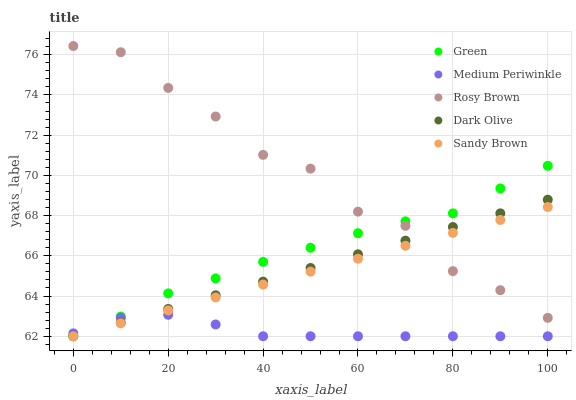Does Medium Periwinkle have the minimum area under the curve?
Answer yes or no. Yes. Does Rosy Brown have the maximum area under the curve?
Answer yes or no. Yes. Does Rosy Brown have the minimum area under the curve?
Answer yes or no. No. Does Medium Periwinkle have the maximum area under the curve?
Answer yes or no. No. Is Sandy Brown the smoothest?
Answer yes or no. Yes. Is Rosy Brown the roughest?
Answer yes or no. Yes. Is Medium Periwinkle the smoothest?
Answer yes or no. No. Is Medium Periwinkle the roughest?
Answer yes or no. No. Does Dark Olive have the lowest value?
Answer yes or no. Yes. Does Rosy Brown have the lowest value?
Answer yes or no. No. Does Rosy Brown have the highest value?
Answer yes or no. Yes. Does Medium Periwinkle have the highest value?
Answer yes or no. No. Is Medium Periwinkle less than Rosy Brown?
Answer yes or no. Yes. Is Rosy Brown greater than Medium Periwinkle?
Answer yes or no. Yes. Does Green intersect Rosy Brown?
Answer yes or no. Yes. Is Green less than Rosy Brown?
Answer yes or no. No. Is Green greater than Rosy Brown?
Answer yes or no. No. Does Medium Periwinkle intersect Rosy Brown?
Answer yes or no. No. 